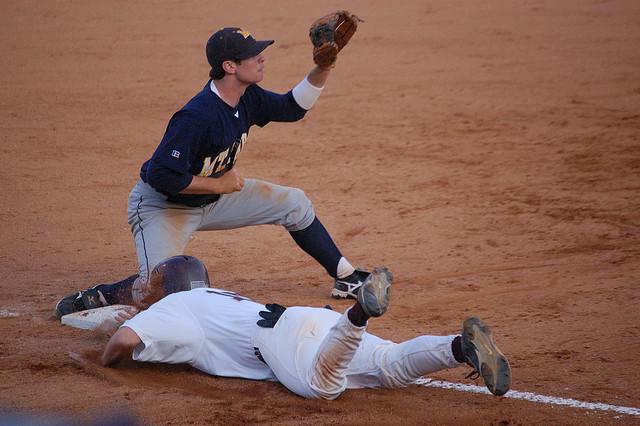Is he safe?
Give a very brief answer. Yes. What color is the shirt?
Write a very short answer. Blue. Is the ball already in the catcher's mitt?
Write a very short answer. No. 